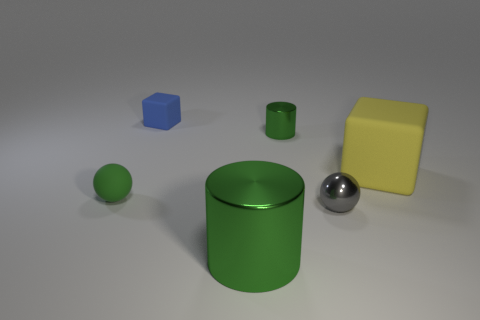Are there any tiny blue rubber objects that have the same shape as the small green shiny thing? Upon revisiting the image, I see that there are no tiny blue rubber objects sharing the same shape as the small green shiny cylinder. However, there is a small blue cube present, which differs in shape from the green cylinder. 